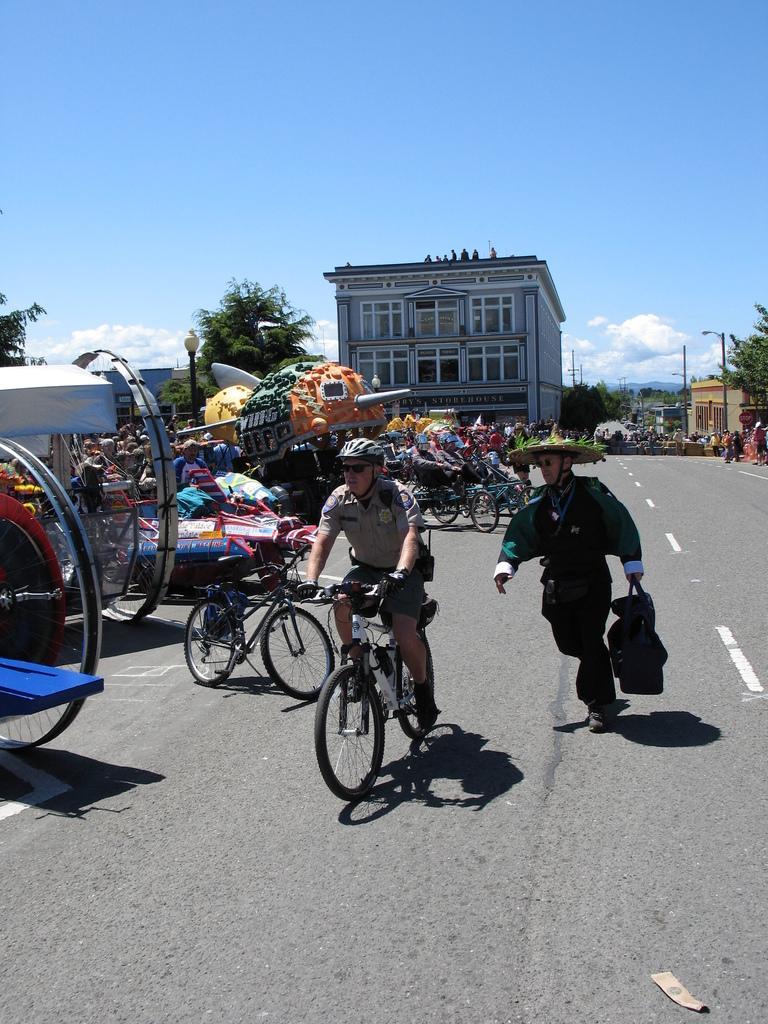Describe this image in one or two sentences. There are lot of people in the image , the first man is riding a bicycle wearing helmet and goggles , the man beside him is standing and holding bag in his right hand and rest of the people are standing on the vehicles. In the background there is a building, sky,clouds and trees 